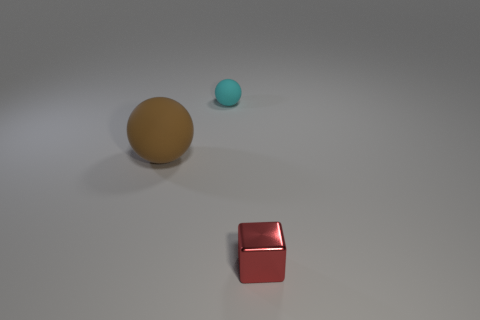There is a tiny shiny thing; are there any small cyan balls left of it?
Your answer should be compact. Yes. Does the red metal cube have the same size as the brown matte object?
Your answer should be very brief. No. There is a object that is left of the cyan matte ball; what is its shape?
Make the answer very short. Sphere. Is there a cyan thing of the same size as the red block?
Your response must be concise. Yes. There is a ball that is the same size as the red shiny object; what is it made of?
Your answer should be very brief. Rubber. What is the size of the matte ball in front of the small cyan matte object?
Your response must be concise. Large. How big is the cyan matte ball?
Make the answer very short. Small. Is the size of the block the same as the matte thing that is behind the big thing?
Your answer should be very brief. Yes. What color is the matte sphere that is on the right side of the rubber sphere that is to the left of the tiny cyan rubber object?
Give a very brief answer. Cyan. Are there an equal number of red blocks to the right of the red cube and metal things in front of the big brown thing?
Offer a terse response. No. 